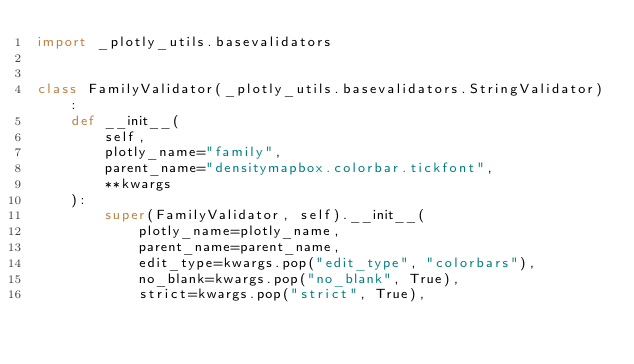<code> <loc_0><loc_0><loc_500><loc_500><_Python_>import _plotly_utils.basevalidators


class FamilyValidator(_plotly_utils.basevalidators.StringValidator):
    def __init__(
        self,
        plotly_name="family",
        parent_name="densitymapbox.colorbar.tickfont",
        **kwargs
    ):
        super(FamilyValidator, self).__init__(
            plotly_name=plotly_name,
            parent_name=parent_name,
            edit_type=kwargs.pop("edit_type", "colorbars"),
            no_blank=kwargs.pop("no_blank", True),
            strict=kwargs.pop("strict", True),</code> 